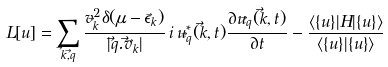Convert formula to latex. <formula><loc_0><loc_0><loc_500><loc_500>L [ u ] = \sum _ { \vec { k } , \vec { q } } \frac { v _ { \vec { k } } ^ { 2 } \delta ( \mu - \epsilon _ { \vec { k } } ) } { | \vec { q } . \vec { v } _ { \vec { k } } | } \, i \, u ^ { \ast } _ { \vec { q } } ( \vec { k } , t ) \frac { \partial u _ { \vec { q } } ( \vec { k } , t ) } { \partial t } - \frac { \langle \{ u \} | H | \{ u \} \rangle } { \langle \{ u \} | \{ u \} \rangle }</formula> 